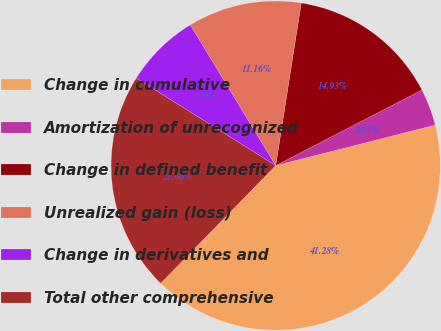<chart> <loc_0><loc_0><loc_500><loc_500><pie_chart><fcel>Change in cumulative<fcel>Amortization of unrecognized<fcel>Change in defined benefit<fcel>Unrealized gain (loss)<fcel>Change in derivatives and<fcel>Total other comprehensive<nl><fcel>41.28%<fcel>3.63%<fcel>14.93%<fcel>11.16%<fcel>7.4%<fcel>21.6%<nl></chart> 